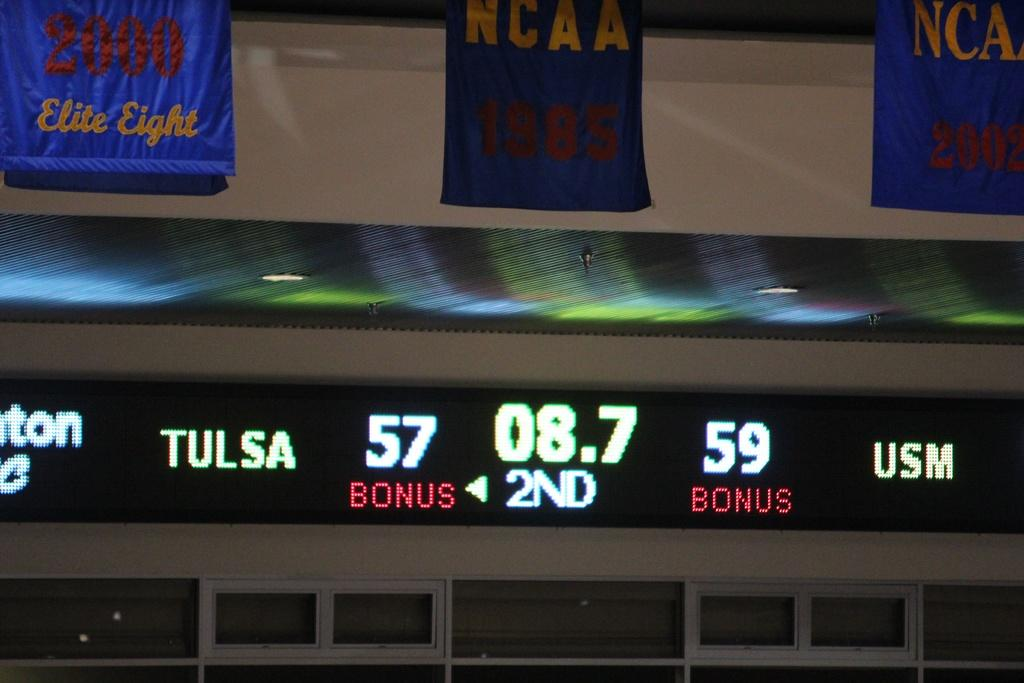Provide a one-sentence caption for the provided image. A scoreboard shows that USM is leading Tulsa 59-57. 